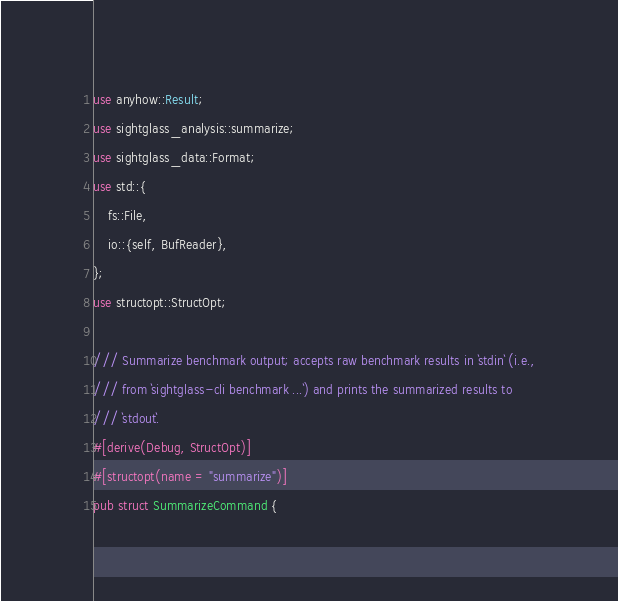Convert code to text. <code><loc_0><loc_0><loc_500><loc_500><_Rust_>use anyhow::Result;
use sightglass_analysis::summarize;
use sightglass_data::Format;
use std::{
    fs::File,
    io::{self, BufReader},
};
use structopt::StructOpt;

/// Summarize benchmark output; accepts raw benchmark results in `stdin` (i.e.,
/// from `sightglass-cli benchmark ...`) and prints the summarized results to
/// `stdout`.
#[derive(Debug, StructOpt)]
#[structopt(name = "summarize")]
pub struct SummarizeCommand {</code> 